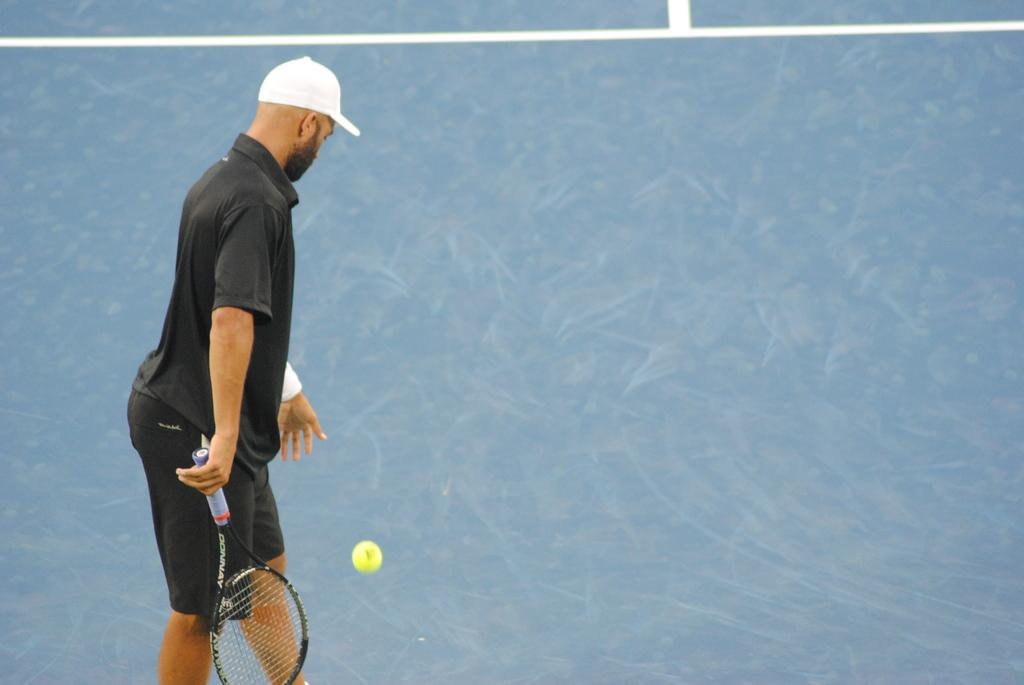What activity is the person in the foreground of the image engaged in? The person is playing badminton in the image. Where is the badminton game taking place? The badminton game is taking place on the ground. When was the image taken? The image was taken during the day. What type of location is the badminton game being played in? The setting is on a pitch. What type of jewel is the person wearing on their wrist in the image? There is no mention of a jewel or anything worn on the person's wrist in the image. How many snails can be seen crawling on the badminton court in the image? There are no snails present in the image; it features a person playing badminton on a pitch. 